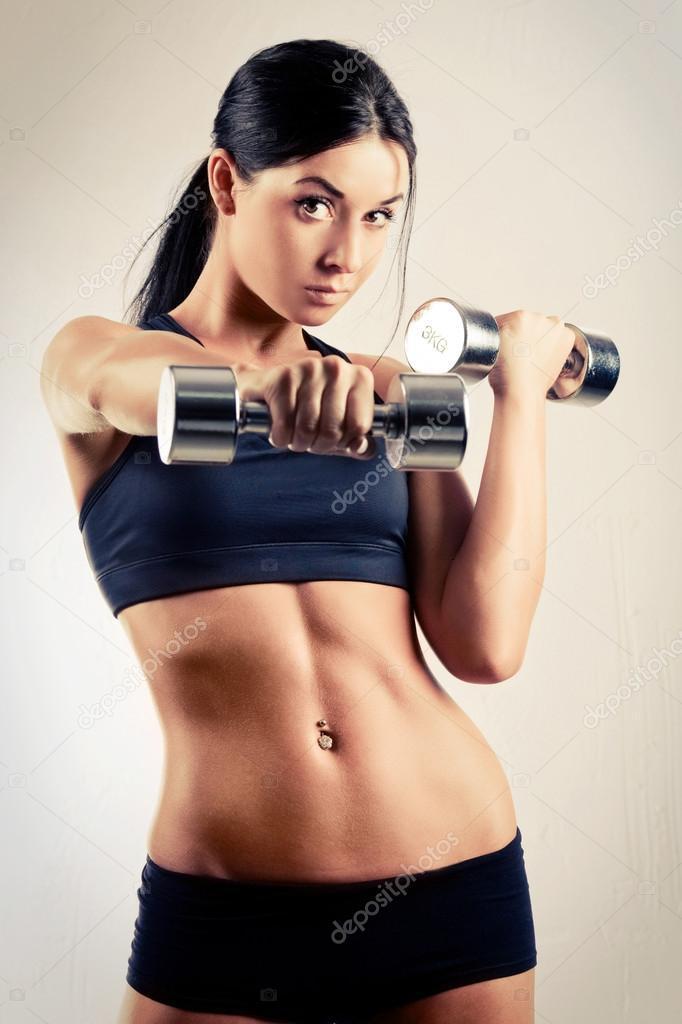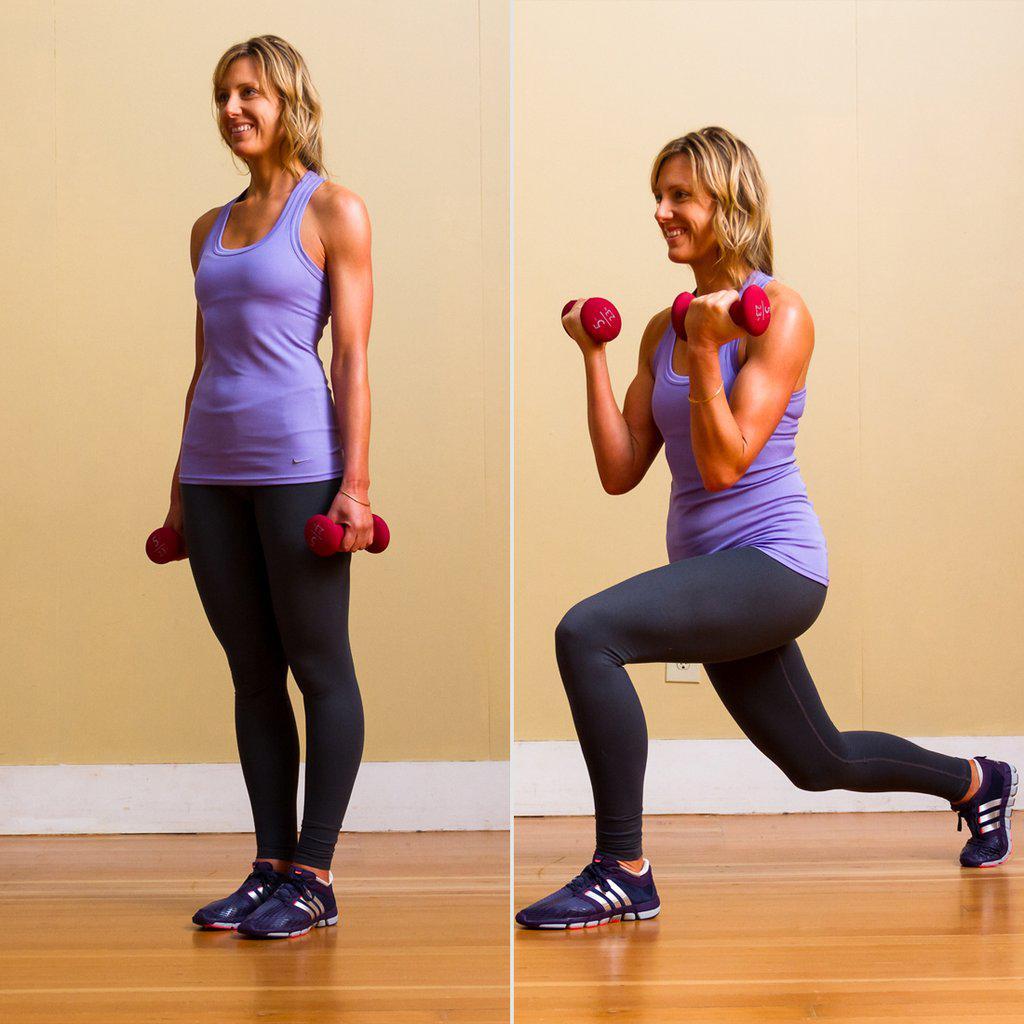The first image is the image on the left, the second image is the image on the right. For the images shown, is this caption "At least one athlete performing a dumbbell workout is a blonde woman in a purple tanktop." true? Answer yes or no. Yes. The first image is the image on the left, the second image is the image on the right. For the images shown, is this caption "The person in the image on the left is lifting a single weight with one hand." true? Answer yes or no. No. 